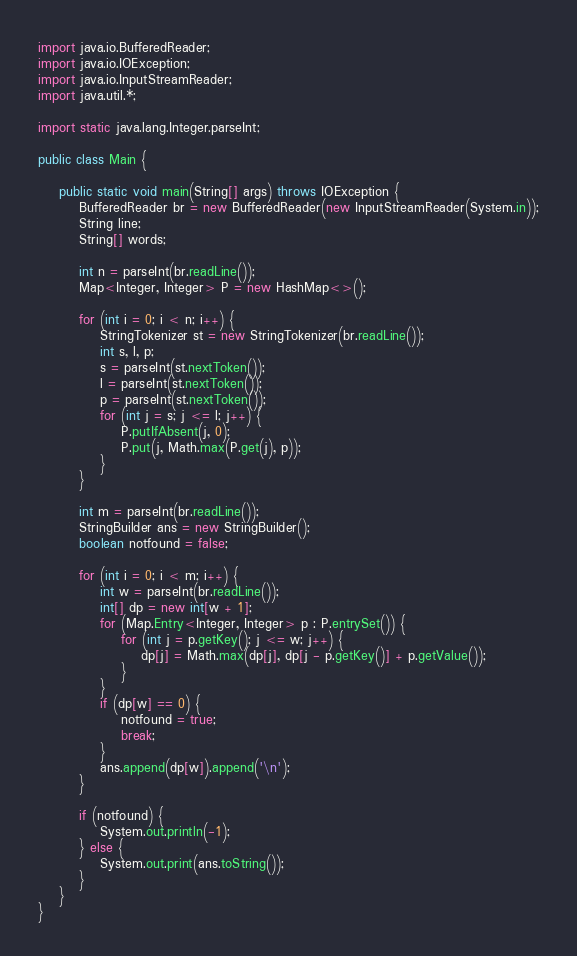<code> <loc_0><loc_0><loc_500><loc_500><_Java_>import java.io.BufferedReader;
import java.io.IOException;
import java.io.InputStreamReader;
import java.util.*;

import static java.lang.Integer.parseInt;

public class Main {

	public static void main(String[] args) throws IOException {
		BufferedReader br = new BufferedReader(new InputStreamReader(System.in));
		String line;
		String[] words;

		int n = parseInt(br.readLine());
		Map<Integer, Integer> P = new HashMap<>();

		for (int i = 0; i < n; i++) {
			StringTokenizer st = new StringTokenizer(br.readLine());
			int s, l, p;
			s = parseInt(st.nextToken());
			l = parseInt(st.nextToken());
			p = parseInt(st.nextToken());
			for (int j = s; j <= l; j++) {
				P.putIfAbsent(j, 0);
				P.put(j, Math.max(P.get(j), p));
			}
		}

		int m = parseInt(br.readLine());
		StringBuilder ans = new StringBuilder();
		boolean notfound = false;

		for (int i = 0; i < m; i++) {
			int w = parseInt(br.readLine());
			int[] dp = new int[w + 1];
			for (Map.Entry<Integer, Integer> p : P.entrySet()) {
				for (int j = p.getKey(); j <= w; j++) {
					dp[j] = Math.max(dp[j], dp[j - p.getKey()] + p.getValue());
				}
			}
			if (dp[w] == 0) {
				notfound = true;
				break;
			}
			ans.append(dp[w]).append('\n');
		}

		if (notfound) {
			System.out.println(-1);
		} else {
			System.out.print(ans.toString());
		}
	}
}

</code> 